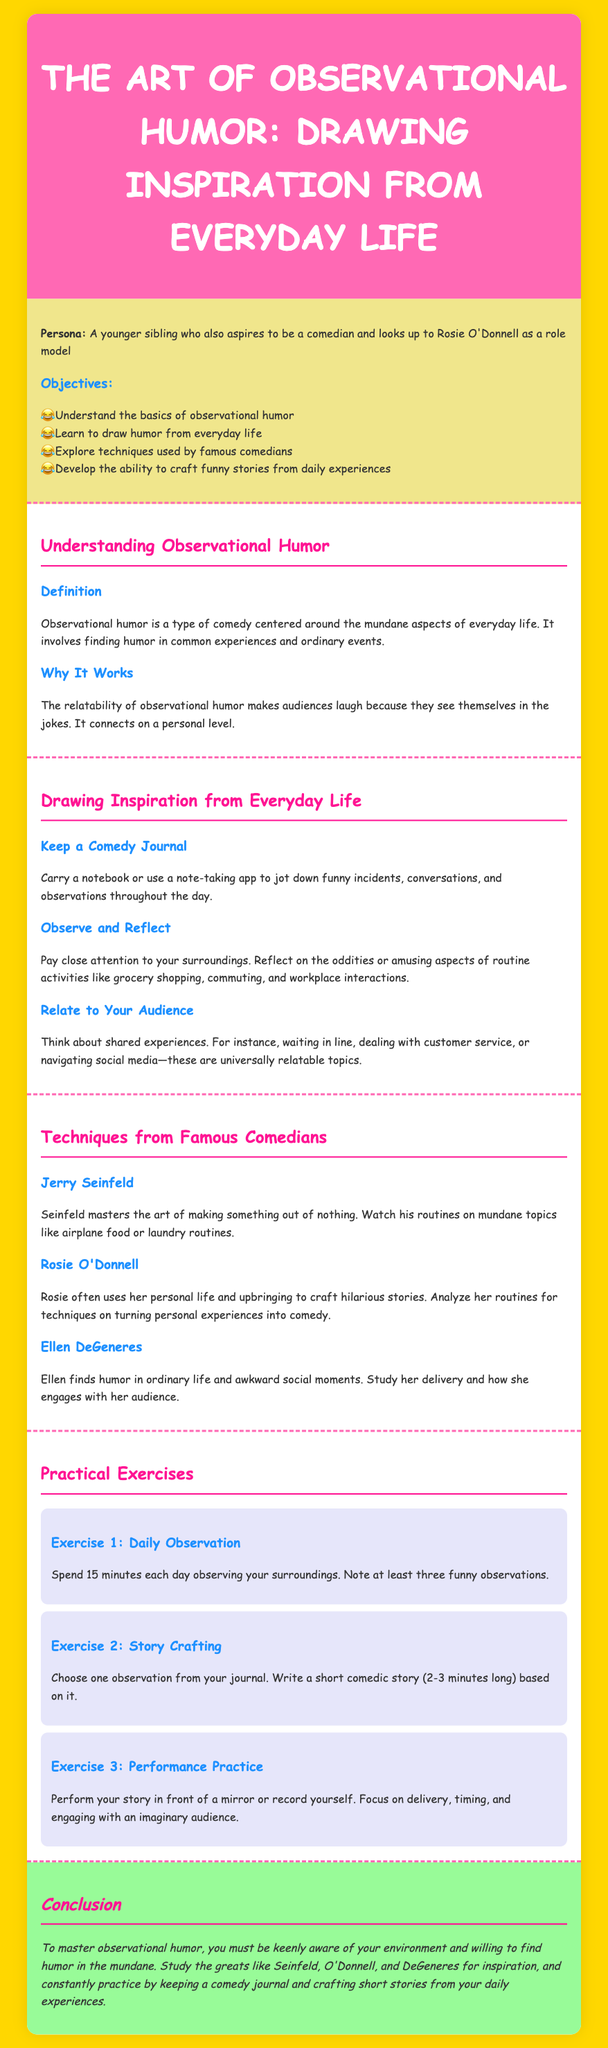what is the main topic of the lesson plan? The main topic is introduced in the title of the document, which focuses on a specific type of comedy.
Answer: The Art of Observational Humor how many objectives are listed in the lesson plan? The number of objectives can be counted in the section under "Objectives."
Answer: Four who is a prominent comedian mentioned in the lesson plan? A famous comedian whose techniques are discussed in the document is given in the techniques section.
Answer: Rosie O'Donnell what is the first exercise listed in the practical exercises? The first exercise can be found in the "Practical Exercises" section, detailing the first activity.
Answer: Daily Observation why does observational humor work according to the document? The reason for its effectiveness is mentioned under "Why It Works," indicating what makes it appealing to audiences.
Answer: Relatability what should one keep to draw humor from everyday life? A specific tool is suggested in the section on drawing inspiration for noting down experiences.
Answer: Comedy Journal how long should Exercise 1 be practiced each day? The duration of the exercise is specified in the description of Exercise 1.
Answer: 15 minutes which comedian is noted for turning personal experiences into comedy? The document names a specific comedian in the "Techniques from Famous Comedians" section for this skill.
Answer: Rosie O'Donnell 